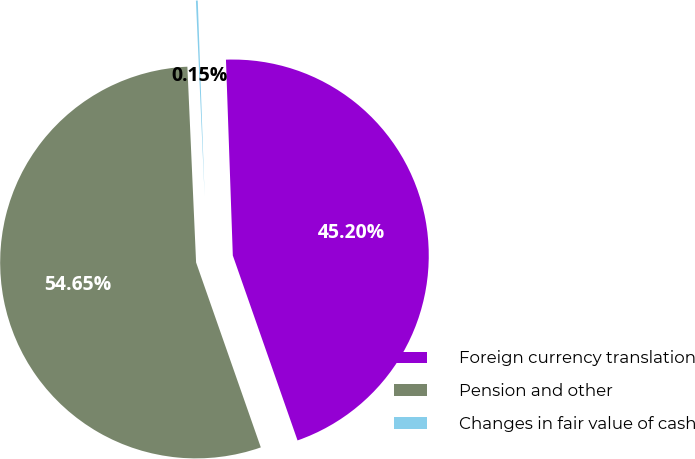Convert chart. <chart><loc_0><loc_0><loc_500><loc_500><pie_chart><fcel>Foreign currency translation<fcel>Pension and other<fcel>Changes in fair value of cash<nl><fcel>45.2%<fcel>54.65%<fcel>0.15%<nl></chart> 